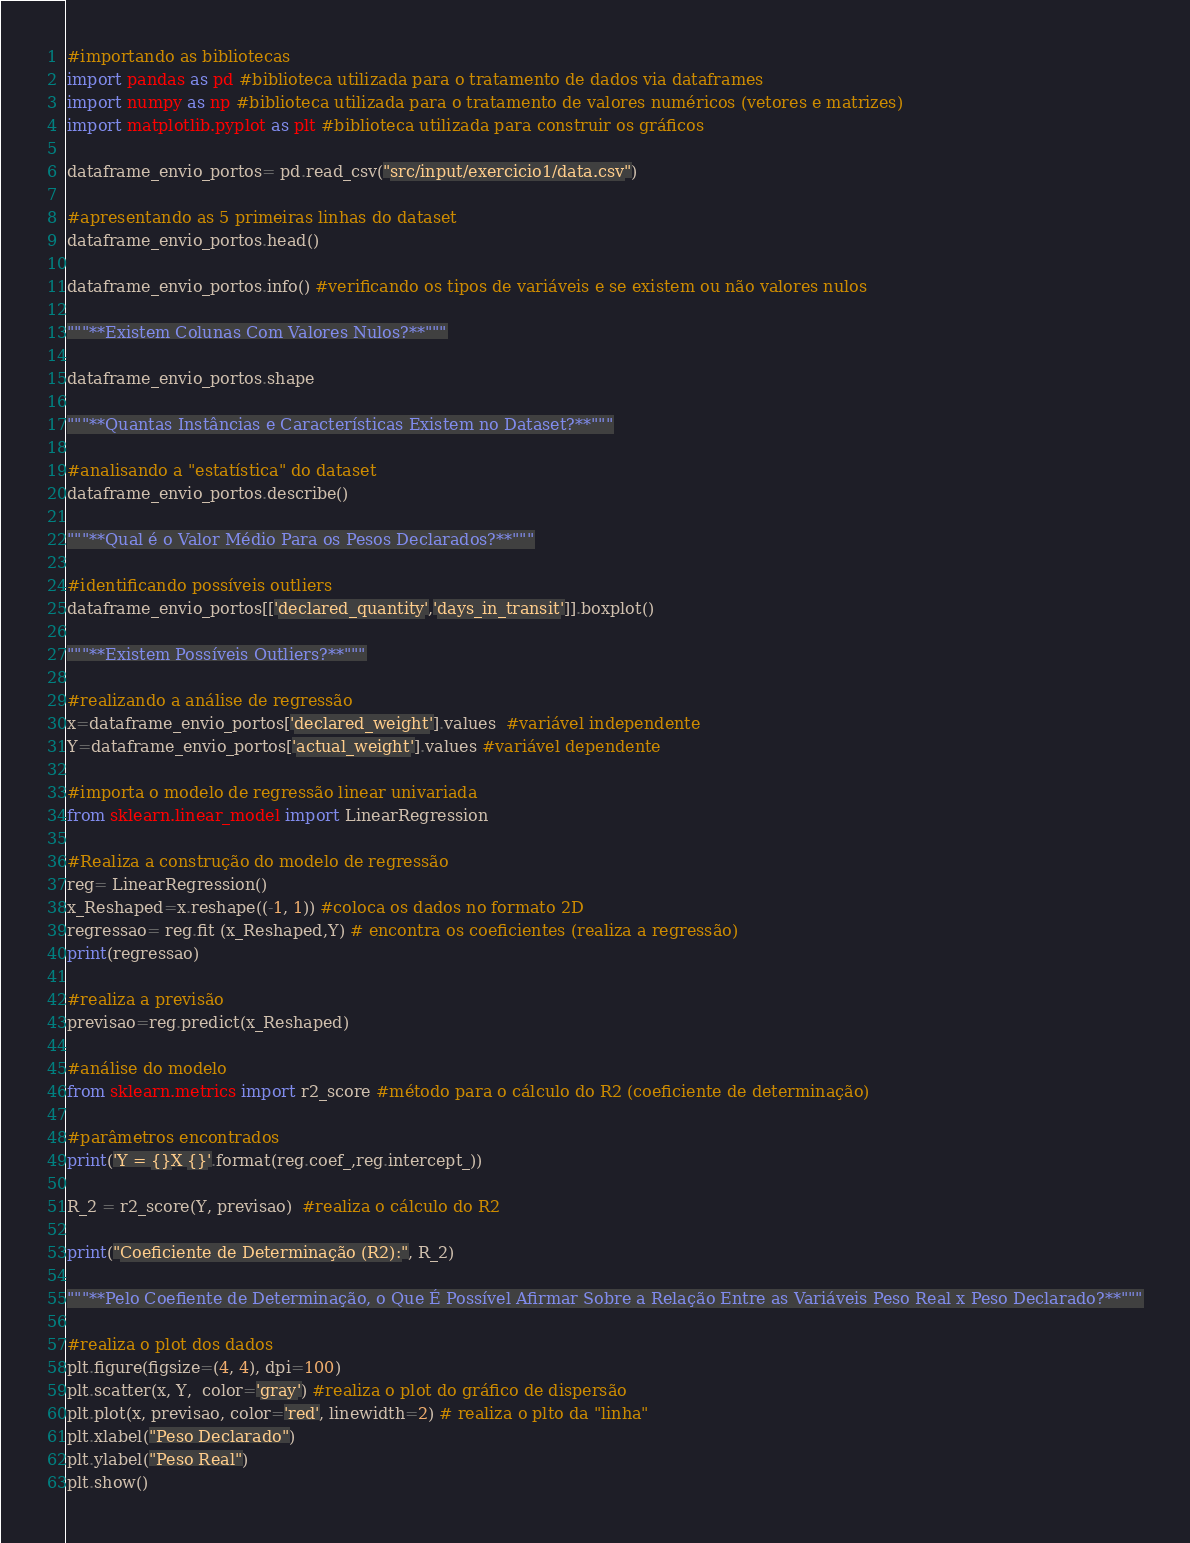Convert code to text. <code><loc_0><loc_0><loc_500><loc_500><_Python_>#importando as bibliotecas
import pandas as pd #biblioteca utilizada para o tratamento de dados via dataframes 
import numpy as np #biblioteca utilizada para o tratamento de valores numéricos (vetores e matrizes)
import matplotlib.pyplot as plt #biblioteca utilizada para construir os gráficos

dataframe_envio_portos= pd.read_csv("src/input/exercicio1/data.csv")

#apresentando as 5 primeiras linhas do dataset
dataframe_envio_portos.head()

dataframe_envio_portos.info() #verificando os tipos de variáveis e se existem ou não valores nulos

"""**Existem Colunas Com Valores Nulos?**"""

dataframe_envio_portos.shape

"""**Quantas Instâncias e Características Existem no Dataset?**"""

#analisando a "estatística" do dataset
dataframe_envio_portos.describe()

"""**Qual é o Valor Médio Para os Pesos Declarados?**"""

#identificando possíveis outliers
dataframe_envio_portos[['declared_quantity','days_in_transit']].boxplot()

"""**Existem Possíveis Outliers?**"""

#realizando a análise de regressão
x=dataframe_envio_portos['declared_weight'].values  #variável independente 
Y=dataframe_envio_portos['actual_weight'].values #variável dependente

#importa o modelo de regressão linear univariada
from sklearn.linear_model import LinearRegression

#Realiza a construção do modelo de regressão
reg= LinearRegression()
x_Reshaped=x.reshape((-1, 1)) #coloca os dados no formato 2D
regressao= reg.fit (x_Reshaped,Y) # encontra os coeficientes (realiza a regressão)
print(regressao)

#realiza a previsão
previsao=reg.predict(x_Reshaped)

#análise do modelo
from sklearn.metrics import r2_score #método para o cálculo do R2 (coeficiente de determinação)

#parâmetros encontrados
print('Y = {}X {}'.format(reg.coef_,reg.intercept_))

R_2 = r2_score(Y, previsao)  #realiza o cálculo do R2

print("Coeficiente de Determinação (R2):", R_2)

"""**Pelo Coefiente de Determinação, o Que É Possível Afirmar Sobre a Relação Entre as Variáveis Peso Real x Peso Declarado?**"""

#realiza o plot dos dados
plt.figure(figsize=(4, 4), dpi=100)
plt.scatter(x, Y,  color='gray') #realiza o plot do gráfico de dispersão
plt.plot(x, previsao, color='red', linewidth=2) # realiza o plto da "linha"
plt.xlabel("Peso Declarado")
plt.ylabel("Peso Real")
plt.show()</code> 